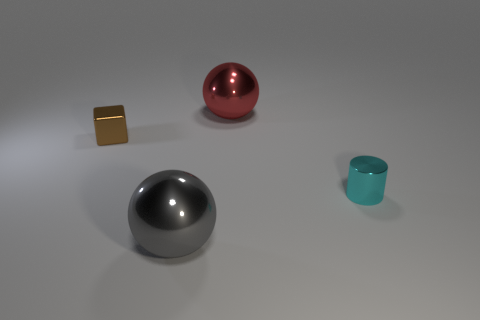How many cylinders are either big gray things or brown shiny objects?
Make the answer very short. 0. What is the size of the cylinder?
Offer a terse response. Small. There is a gray shiny ball; what number of metal cylinders are to the left of it?
Provide a succinct answer. 0. There is a object that is on the right side of the big thing that is to the right of the big gray metallic sphere; how big is it?
Offer a terse response. Small. Is the shape of the tiny brown object in front of the large red object the same as the metal object that is in front of the small metal cylinder?
Provide a short and direct response. No. There is a large object that is to the right of the big shiny ball in front of the small cyan cylinder; what shape is it?
Provide a succinct answer. Sphere. There is a thing that is both on the right side of the tiny metallic block and behind the cyan metal object; what size is it?
Provide a succinct answer. Large. Do the gray metal object and the object that is behind the small brown metallic block have the same shape?
Provide a short and direct response. Yes. The other metallic thing that is the same shape as the red object is what size?
Ensure brevity in your answer.  Large. The thing that is left of the metallic sphere that is to the left of the big metal sphere behind the big gray object is what shape?
Keep it short and to the point. Cube. 